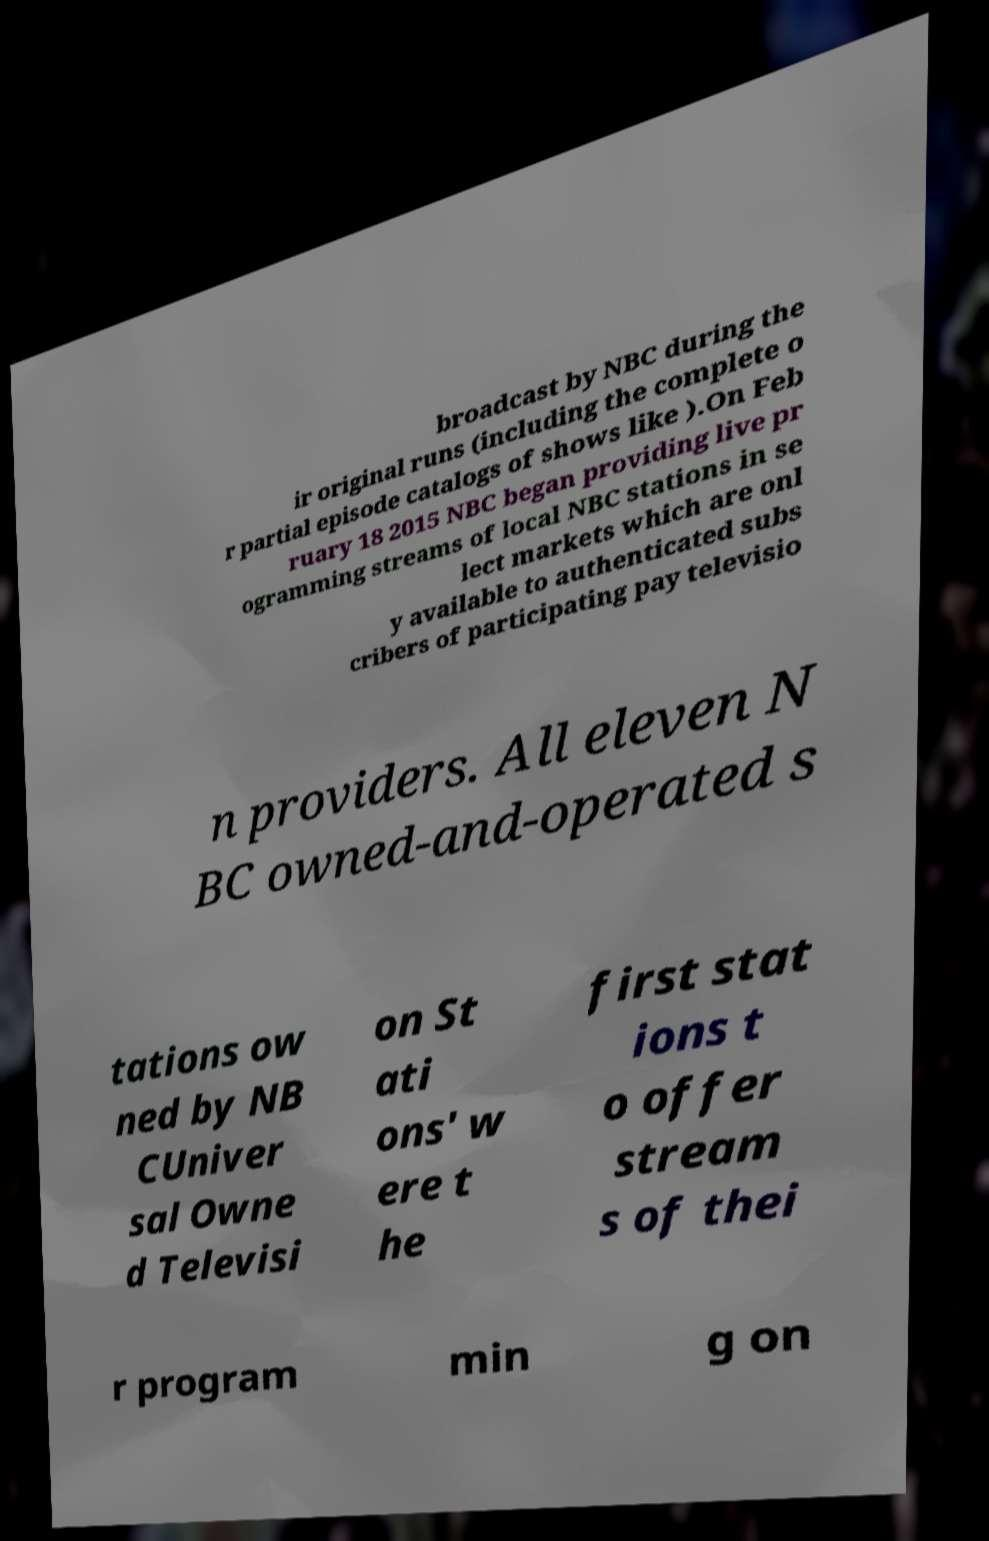Can you accurately transcribe the text from the provided image for me? broadcast by NBC during the ir original runs (including the complete o r partial episode catalogs of shows like ).On Feb ruary 18 2015 NBC began providing live pr ogramming streams of local NBC stations in se lect markets which are onl y available to authenticated subs cribers of participating pay televisio n providers. All eleven N BC owned-and-operated s tations ow ned by NB CUniver sal Owne d Televisi on St ati ons' w ere t he first stat ions t o offer stream s of thei r program min g on 